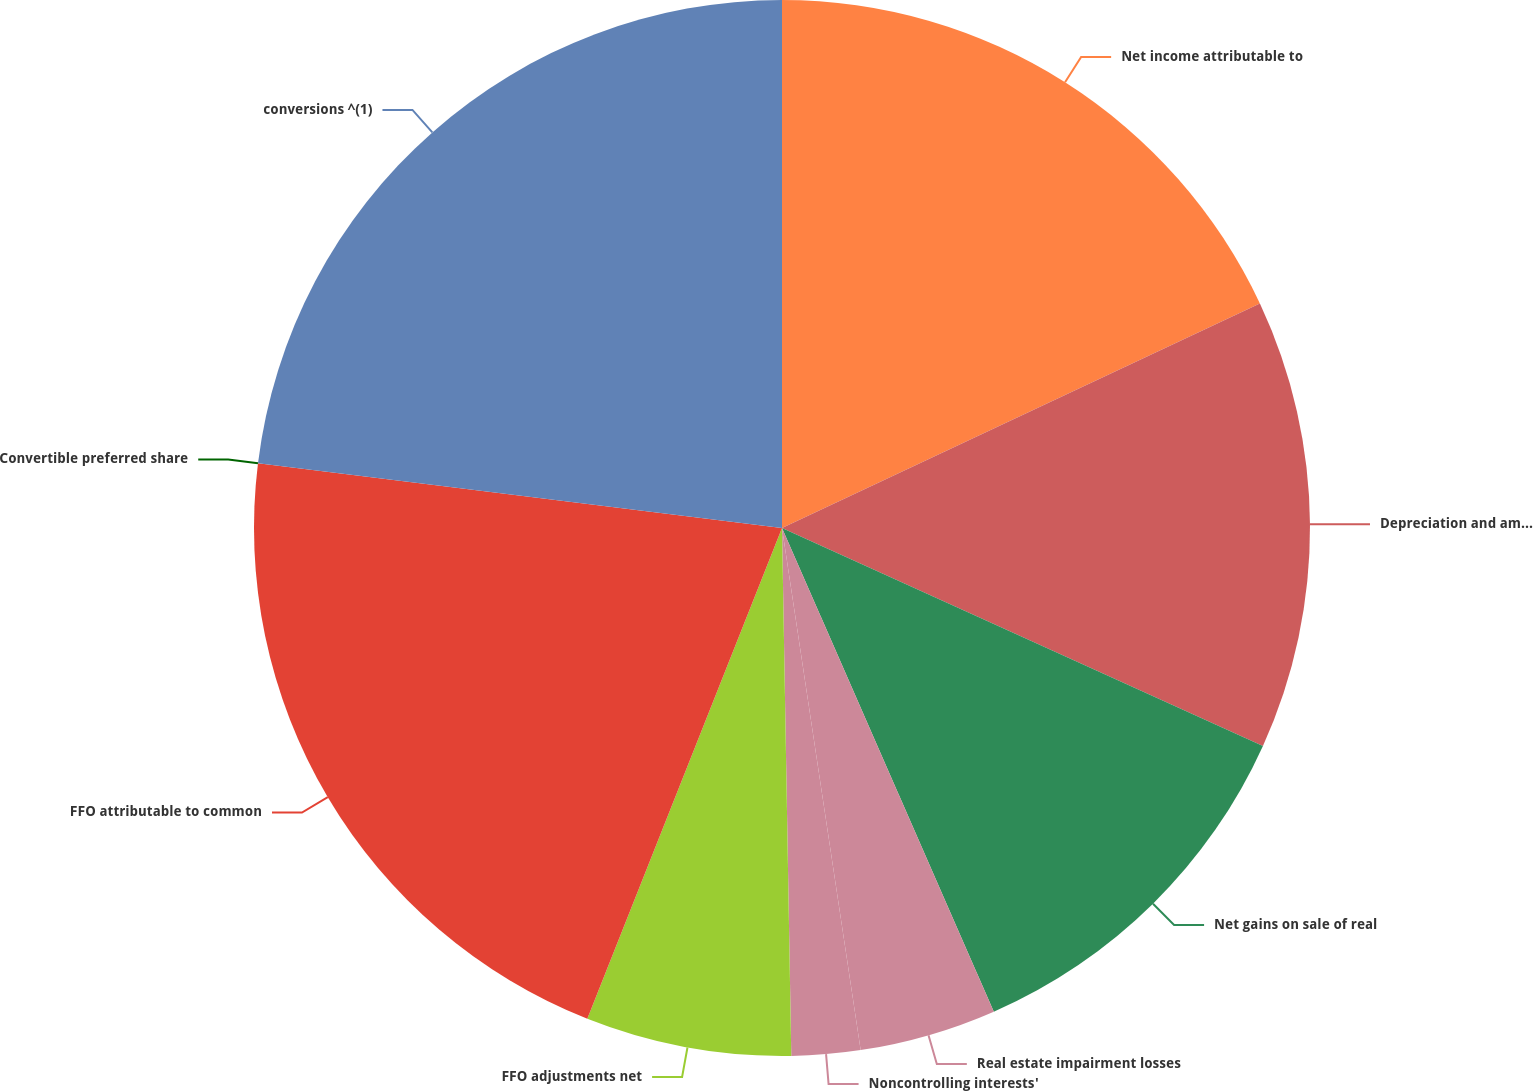<chart> <loc_0><loc_0><loc_500><loc_500><pie_chart><fcel>Net income attributable to<fcel>Depreciation and amortization<fcel>Net gains on sale of real<fcel>Real estate impairment losses<fcel>Noncontrolling interests'<fcel>FFO adjustments net<fcel>FFO attributable to common<fcel>Convertible preferred share<fcel>conversions ^(1)<nl><fcel>18.01%<fcel>13.76%<fcel>11.66%<fcel>4.19%<fcel>2.1%<fcel>6.29%<fcel>20.95%<fcel>0.0%<fcel>23.04%<nl></chart> 